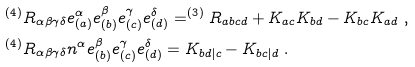Convert formula to latex. <formula><loc_0><loc_0><loc_500><loc_500>& ^ { ( 4 ) } R _ { \alpha \beta \gamma \delta } e _ { ( a ) } ^ { \alpha } e _ { ( b ) } ^ { \beta } e _ { ( c ) } ^ { \gamma } e _ { ( d ) } ^ { \delta } = ^ { ( 3 ) } R _ { a b c d } + K _ { a c } K _ { b d } - K _ { b c } K _ { a d } \ , \\ & ^ { ( 4 ) } R _ { \alpha \beta \gamma \delta } n ^ { \alpha } e _ { ( b ) } ^ { \beta } e _ { ( c ) } ^ { \gamma } e _ { ( d ) } ^ { \delta } = K _ { b d | c } - K _ { b c | d } \ .</formula> 